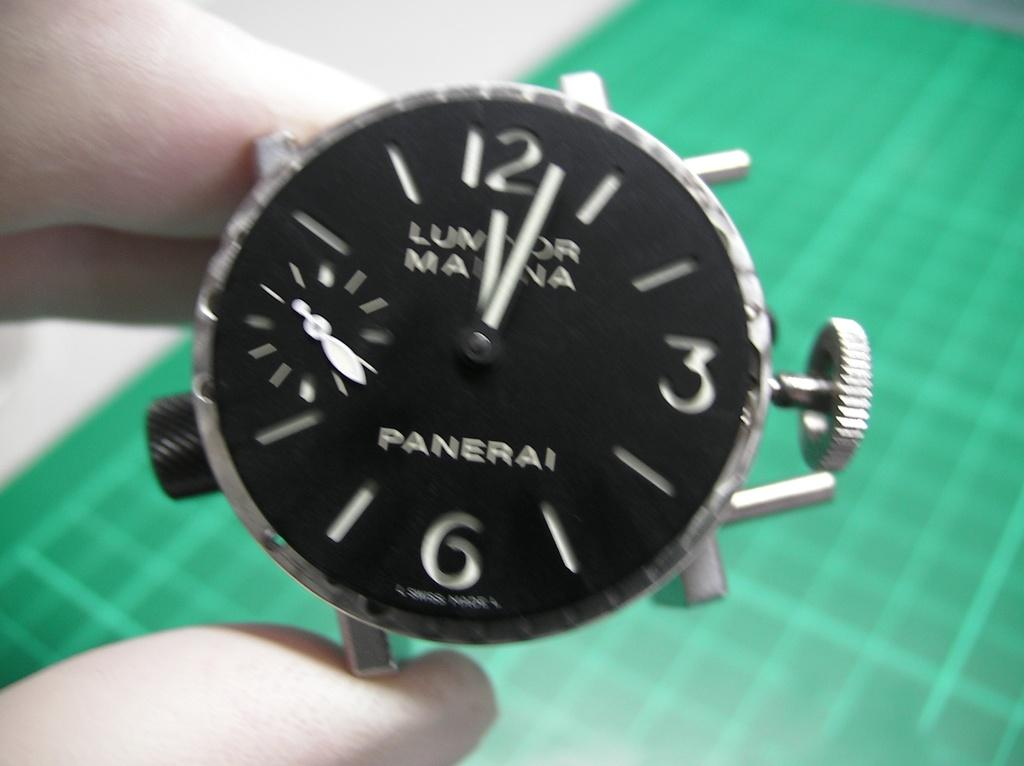<image>
Give a short and clear explanation of the subsequent image. A black watch face has the number 6 on it and is above a green board. 